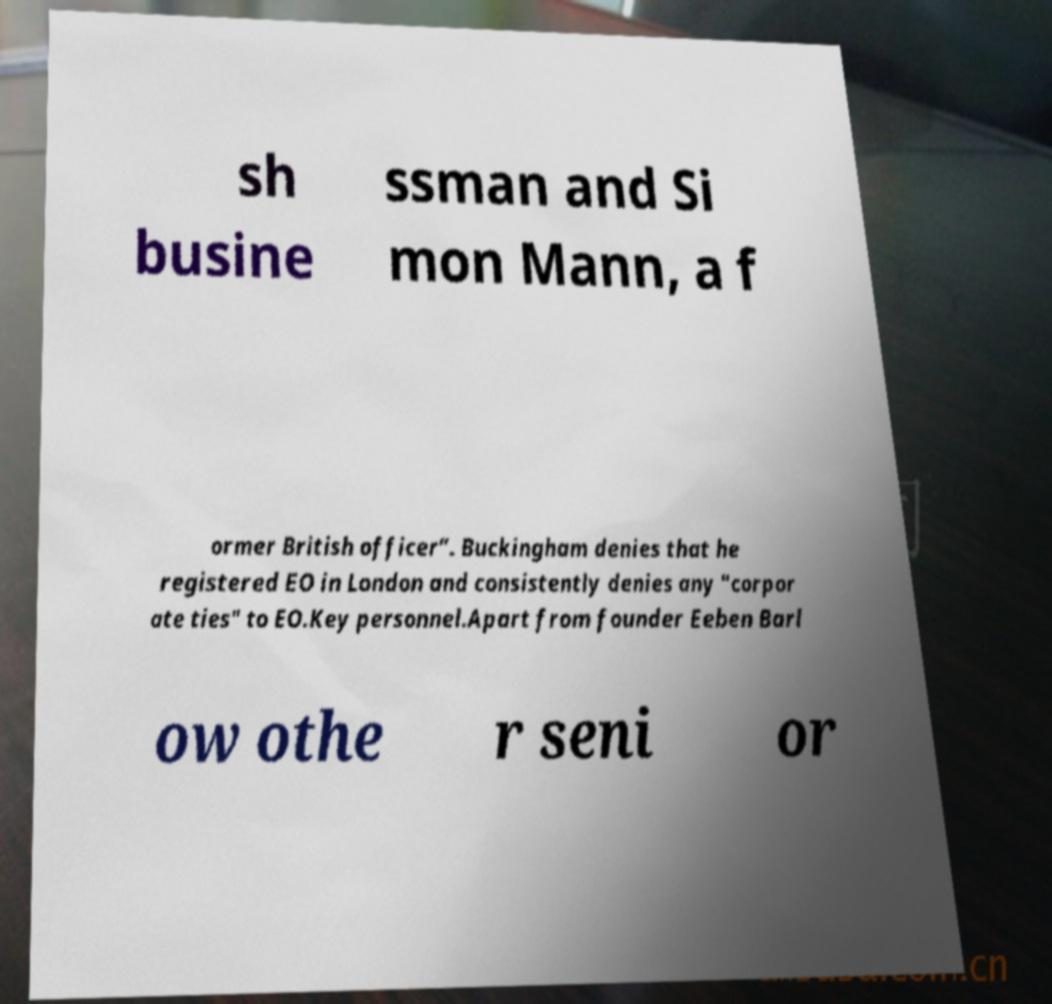Can you accurately transcribe the text from the provided image for me? sh busine ssman and Si mon Mann, a f ormer British officer”. Buckingham denies that he registered EO in London and consistently denies any "corpor ate ties" to EO.Key personnel.Apart from founder Eeben Barl ow othe r seni or 